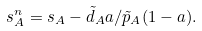<formula> <loc_0><loc_0><loc_500><loc_500>s _ { A } ^ { n } = s _ { A } - \tilde { d } _ { A } a / \tilde { p } _ { A } ( 1 - a ) .</formula> 